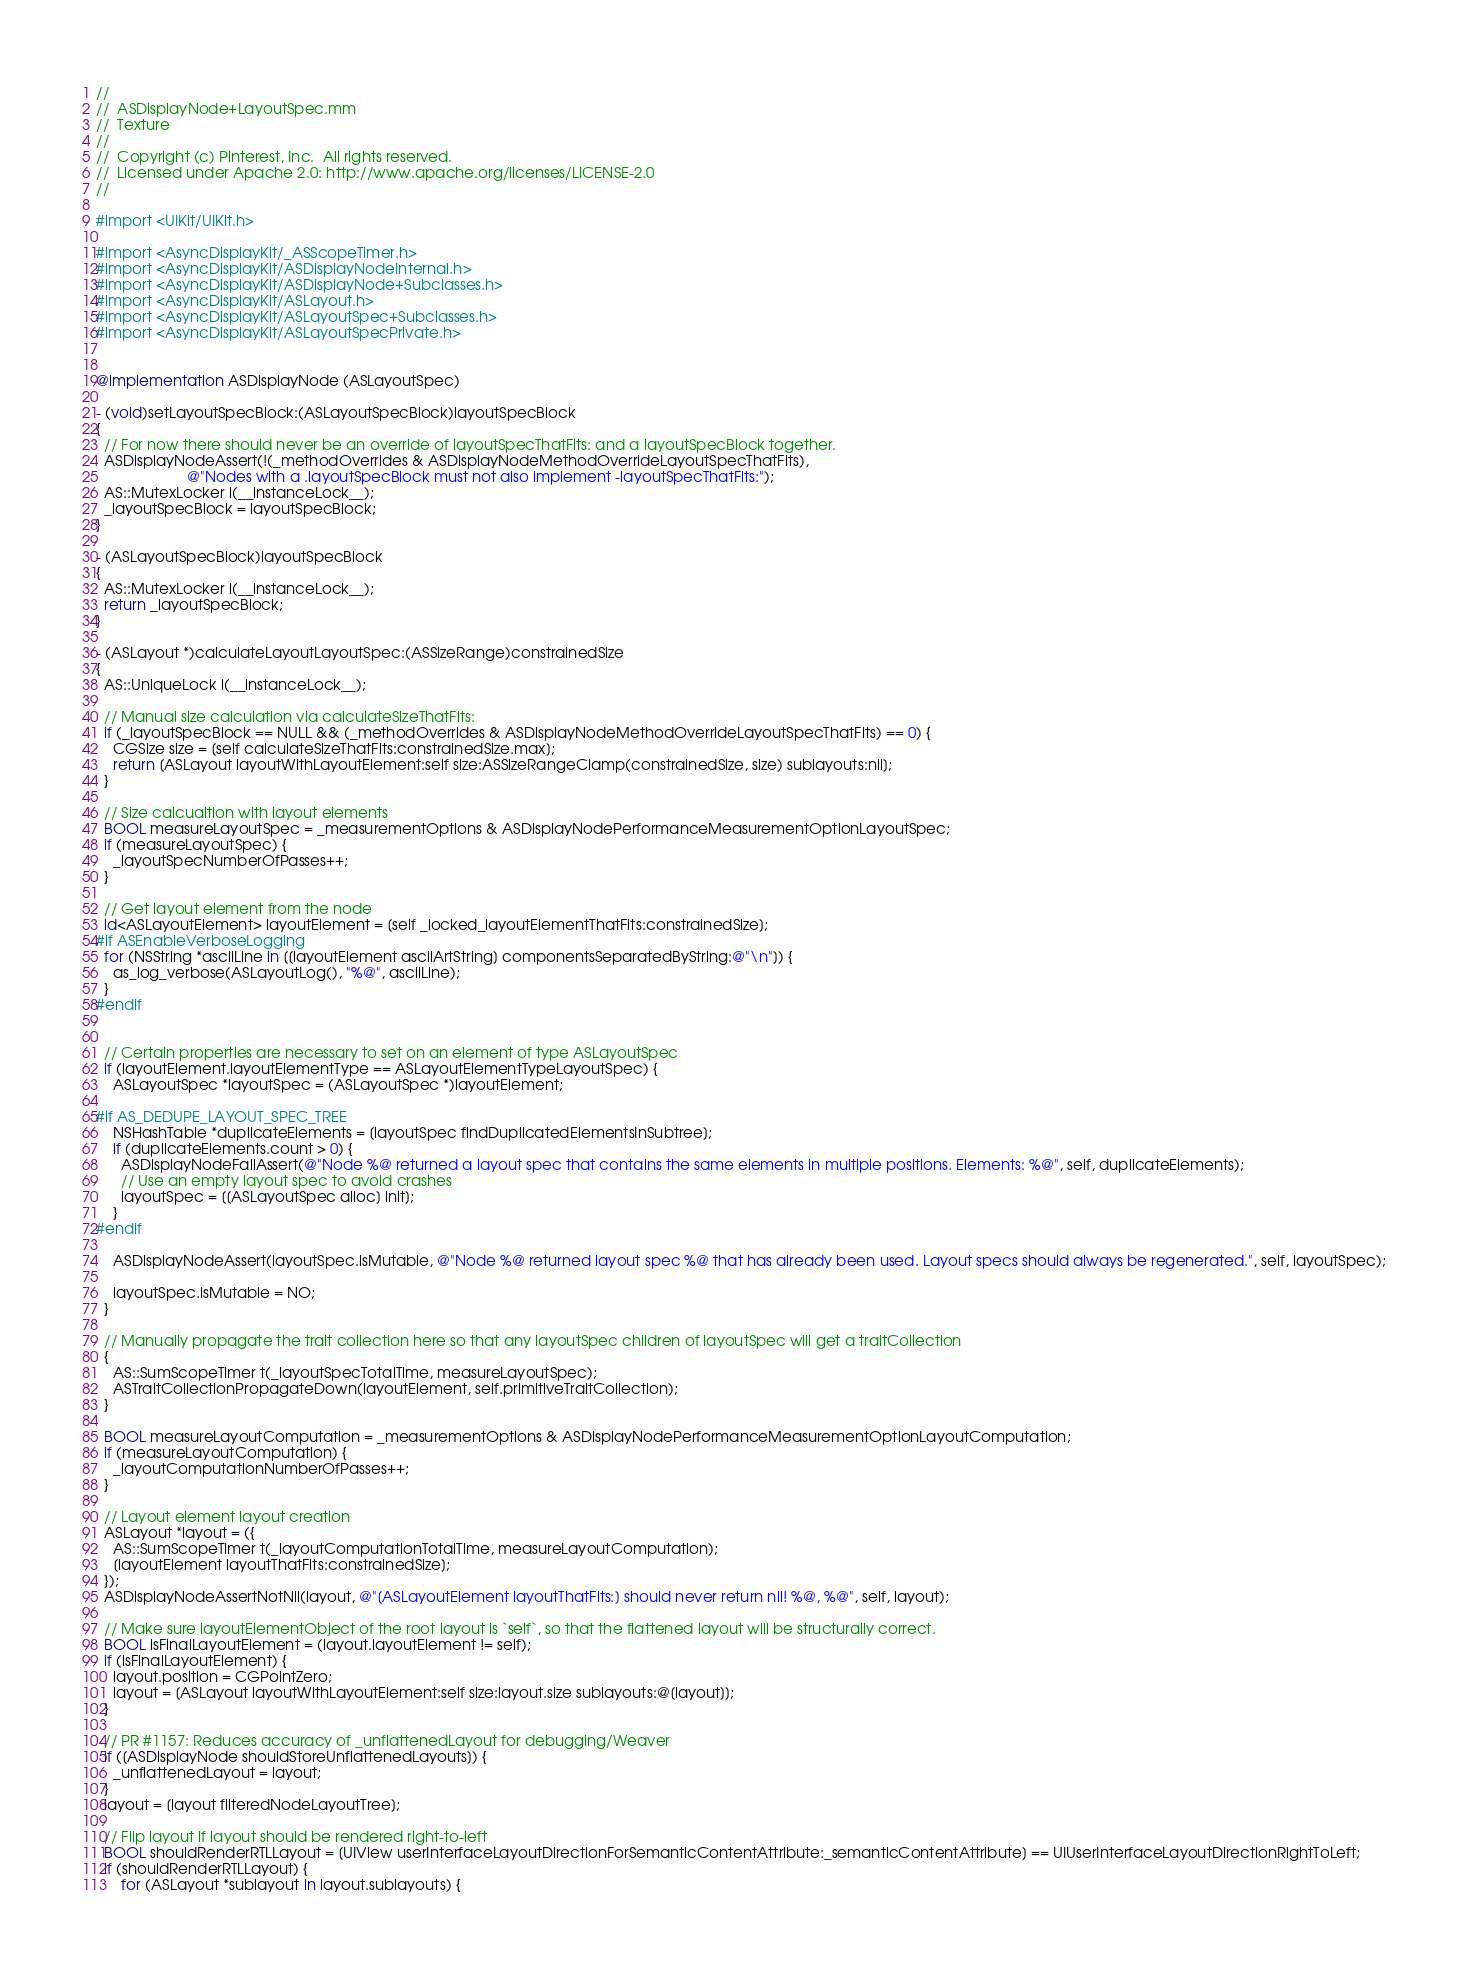Convert code to text. <code><loc_0><loc_0><loc_500><loc_500><_ObjectiveC_>//
//  ASDisplayNode+LayoutSpec.mm
//  Texture
//
//  Copyright (c) Pinterest, Inc.  All rights reserved.
//  Licensed under Apache 2.0: http://www.apache.org/licenses/LICENSE-2.0
//

#import <UIKit/UIKit.h>

#import <AsyncDisplayKit/_ASScopeTimer.h>
#import <AsyncDisplayKit/ASDisplayNodeInternal.h>
#import <AsyncDisplayKit/ASDisplayNode+Subclasses.h>
#import <AsyncDisplayKit/ASLayout.h>
#import <AsyncDisplayKit/ASLayoutSpec+Subclasses.h>
#import <AsyncDisplayKit/ASLayoutSpecPrivate.h>


@implementation ASDisplayNode (ASLayoutSpec)

- (void)setLayoutSpecBlock:(ASLayoutSpecBlock)layoutSpecBlock
{
  // For now there should never be an override of layoutSpecThatFits: and a layoutSpecBlock together.
  ASDisplayNodeAssert(!(_methodOverrides & ASDisplayNodeMethodOverrideLayoutSpecThatFits),
                      @"Nodes with a .layoutSpecBlock must not also implement -layoutSpecThatFits:");
  AS::MutexLocker l(__instanceLock__);
  _layoutSpecBlock = layoutSpecBlock;
}

- (ASLayoutSpecBlock)layoutSpecBlock
{
  AS::MutexLocker l(__instanceLock__);
  return _layoutSpecBlock;
}

- (ASLayout *)calculateLayoutLayoutSpec:(ASSizeRange)constrainedSize
{
  AS::UniqueLock l(__instanceLock__);

  // Manual size calculation via calculateSizeThatFits:
  if (_layoutSpecBlock == NULL && (_methodOverrides & ASDisplayNodeMethodOverrideLayoutSpecThatFits) == 0) {
    CGSize size = [self calculateSizeThatFits:constrainedSize.max];
    return [ASLayout layoutWithLayoutElement:self size:ASSizeRangeClamp(constrainedSize, size) sublayouts:nil];
  }

  // Size calcualtion with layout elements
  BOOL measureLayoutSpec = _measurementOptions & ASDisplayNodePerformanceMeasurementOptionLayoutSpec;
  if (measureLayoutSpec) {
    _layoutSpecNumberOfPasses++;
  }

  // Get layout element from the node
  id<ASLayoutElement> layoutElement = [self _locked_layoutElementThatFits:constrainedSize];
#if ASEnableVerboseLogging
  for (NSString *asciiLine in [[layoutElement asciiArtString] componentsSeparatedByString:@"\n"]) {
    as_log_verbose(ASLayoutLog(), "%@", asciiLine);
  }
#endif


  // Certain properties are necessary to set on an element of type ASLayoutSpec
  if (layoutElement.layoutElementType == ASLayoutElementTypeLayoutSpec) {
    ASLayoutSpec *layoutSpec = (ASLayoutSpec *)layoutElement;

#if AS_DEDUPE_LAYOUT_SPEC_TREE
    NSHashTable *duplicateElements = [layoutSpec findDuplicatedElementsInSubtree];
    if (duplicateElements.count > 0) {
      ASDisplayNodeFailAssert(@"Node %@ returned a layout spec that contains the same elements in multiple positions. Elements: %@", self, duplicateElements);
      // Use an empty layout spec to avoid crashes
      layoutSpec = [[ASLayoutSpec alloc] init];
    }
#endif

    ASDisplayNodeAssert(layoutSpec.isMutable, @"Node %@ returned layout spec %@ that has already been used. Layout specs should always be regenerated.", self, layoutSpec);

    layoutSpec.isMutable = NO;
  }

  // Manually propagate the trait collection here so that any layoutSpec children of layoutSpec will get a traitCollection
  {
    AS::SumScopeTimer t(_layoutSpecTotalTime, measureLayoutSpec);
    ASTraitCollectionPropagateDown(layoutElement, self.primitiveTraitCollection);
  }

  BOOL measureLayoutComputation = _measurementOptions & ASDisplayNodePerformanceMeasurementOptionLayoutComputation;
  if (measureLayoutComputation) {
    _layoutComputationNumberOfPasses++;
  }

  // Layout element layout creation
  ASLayout *layout = ({
    AS::SumScopeTimer t(_layoutComputationTotalTime, measureLayoutComputation);
    [layoutElement layoutThatFits:constrainedSize];
  });
  ASDisplayNodeAssertNotNil(layout, @"[ASLayoutElement layoutThatFits:] should never return nil! %@, %@", self, layout);

  // Make sure layoutElementObject of the root layout is `self`, so that the flattened layout will be structurally correct.
  BOOL isFinalLayoutElement = (layout.layoutElement != self);
  if (isFinalLayoutElement) {
    layout.position = CGPointZero;
    layout = [ASLayout layoutWithLayoutElement:self size:layout.size sublayouts:@[layout]];
  }

  // PR #1157: Reduces accuracy of _unflattenedLayout for debugging/Weaver
  if ([ASDisplayNode shouldStoreUnflattenedLayouts]) {
    _unflattenedLayout = layout;
  }
  layout = [layout filteredNodeLayoutTree];

  // Flip layout if layout should be rendered right-to-left
  BOOL shouldRenderRTLLayout = [UIView userInterfaceLayoutDirectionForSemanticContentAttribute:_semanticContentAttribute] == UIUserInterfaceLayoutDirectionRightToLeft;
  if (shouldRenderRTLLayout) {
      for (ASLayout *sublayout in layout.sublayouts) {</code> 